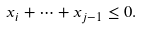<formula> <loc_0><loc_0><loc_500><loc_500>x _ { i } + \dots + x _ { j - 1 } \leq 0 .</formula> 